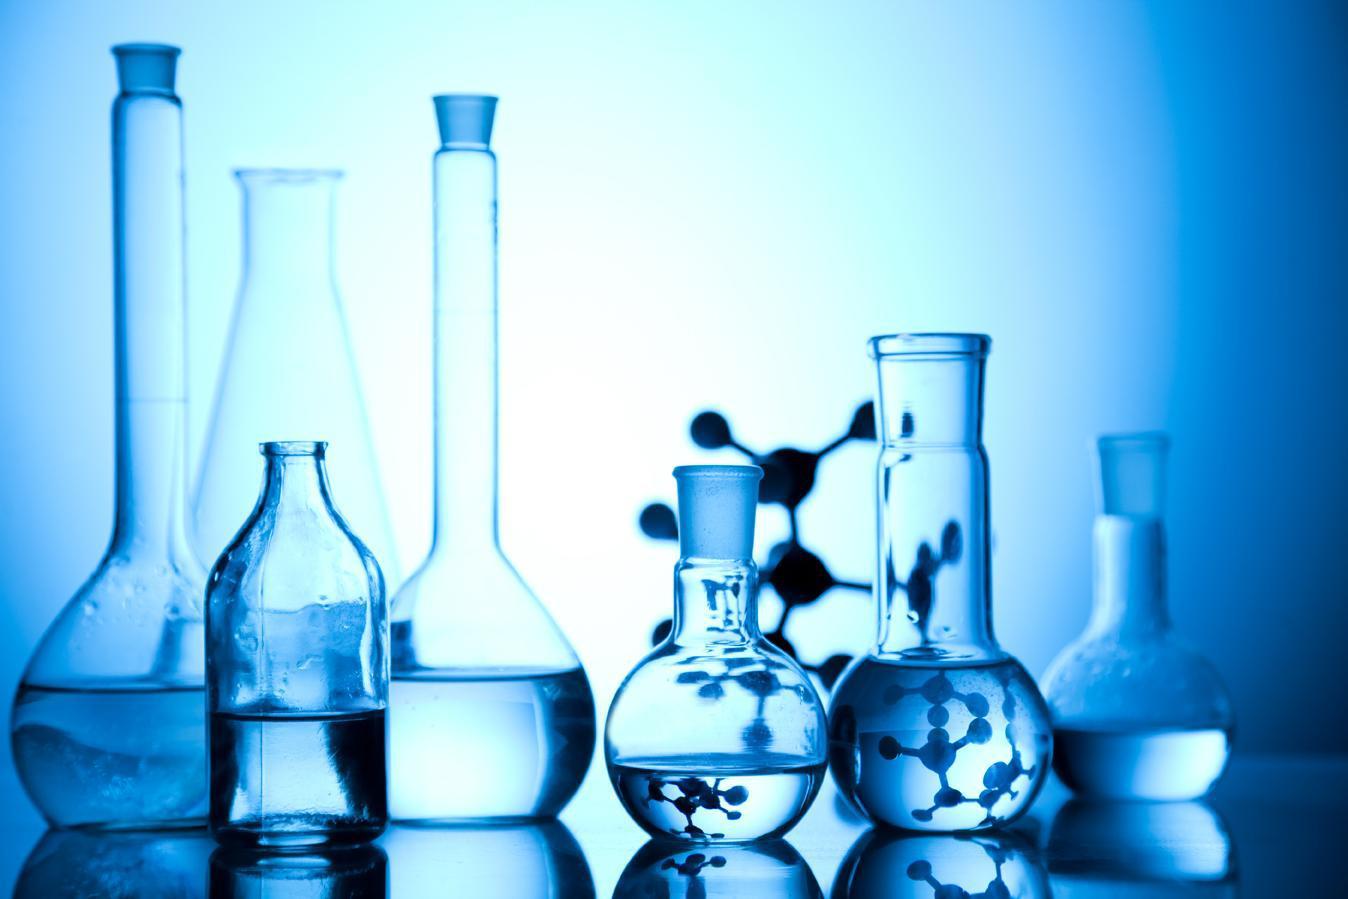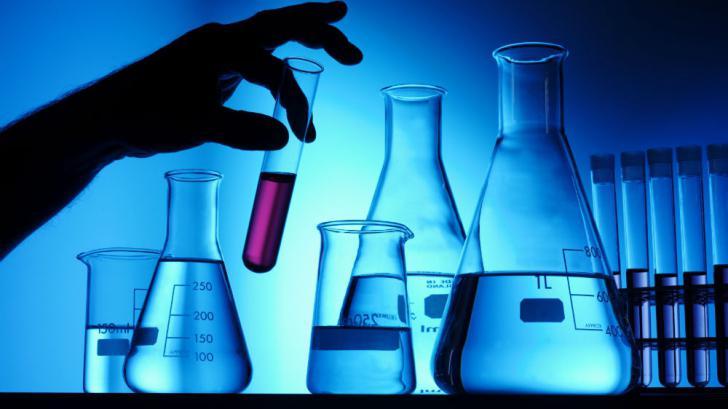The first image is the image on the left, the second image is the image on the right. Assess this claim about the two images: "A blue light glows behind the containers in the image on the left.". Correct or not? Answer yes or no. Yes. The first image is the image on the left, the second image is the image on the right. Evaluate the accuracy of this statement regarding the images: "There is at least one beaker straw of stir stick.". Is it true? Answer yes or no. No. 